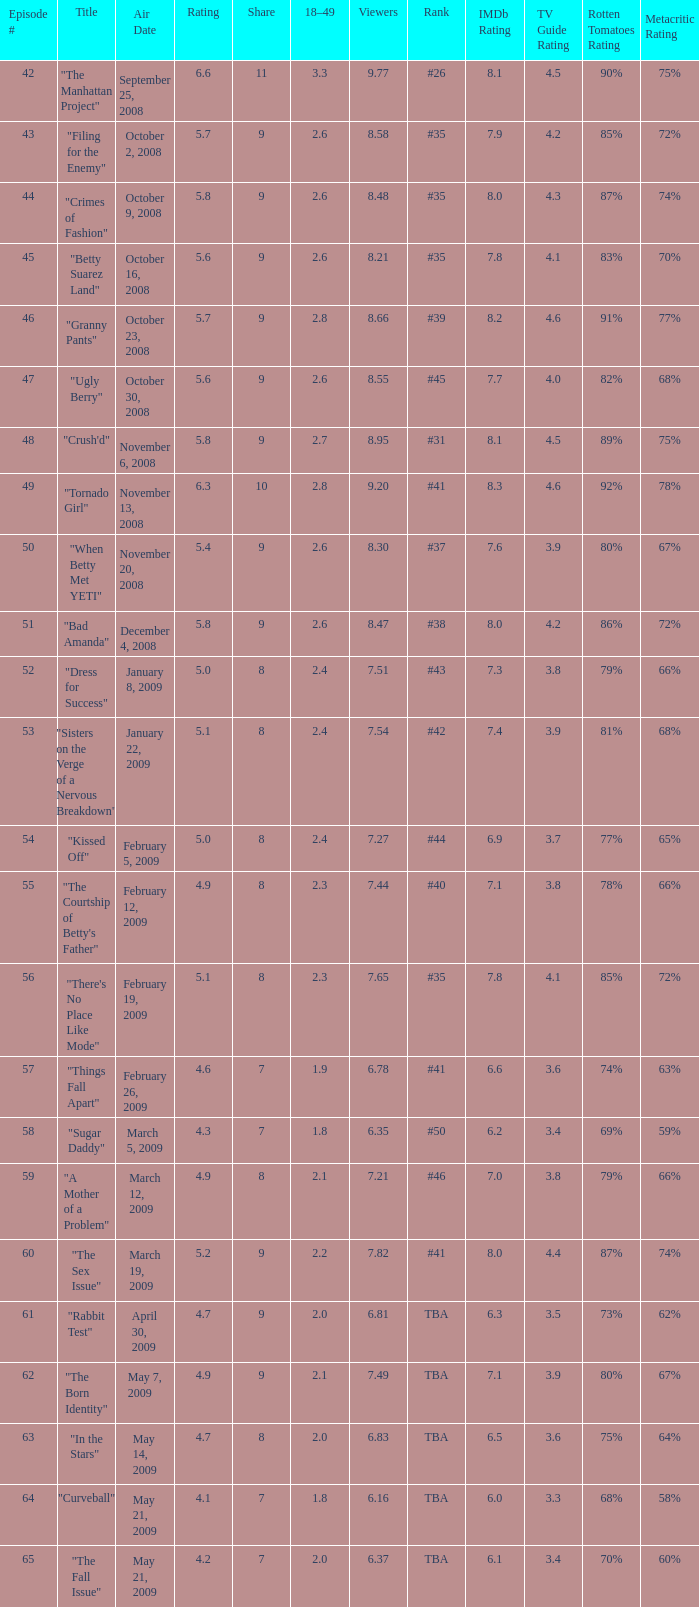What is the total viewer count for a rank of #40? 1.0. Would you mind parsing the complete table? {'header': ['Episode #', 'Title', 'Air Date', 'Rating', 'Share', '18–49', 'Viewers', 'Rank', 'IMDb Rating', 'TV Guide Rating', 'Rotten Tomatoes Rating', 'Metacritic Rating'], 'rows': [['42', '"The Manhattan Project"', 'September 25, 2008', '6.6', '11', '3.3', '9.77', '#26', '8.1', '4.5', '90%', '75%'], ['43', '"Filing for the Enemy"', 'October 2, 2008', '5.7', '9', '2.6', '8.58', '#35', '7.9', '4.2', '85%', '72%'], ['44', '"Crimes of Fashion"', 'October 9, 2008', '5.8', '9', '2.6', '8.48', '#35', '8.0', '4.3', '87%', '74%'], ['45', '"Betty Suarez Land"', 'October 16, 2008', '5.6', '9', '2.6', '8.21', '#35', '7.8', '4.1', '83%', '70%'], ['46', '"Granny Pants"', 'October 23, 2008', '5.7', '9', '2.8', '8.66', '#39', '8.2', '4.6', '91%', '77%'], ['47', '"Ugly Berry"', 'October 30, 2008', '5.6', '9', '2.6', '8.55', '#45', '7.7', '4.0', '82%', '68%'], ['48', '"Crush\'d"', 'November 6, 2008', '5.8', '9', '2.7', '8.95', '#31', '8.1', '4.5', '89%', '75%'], ['49', '"Tornado Girl"', 'November 13, 2008', '6.3', '10', '2.8', '9.20', '#41', '8.3', '4.6', '92%', '78%'], ['50', '"When Betty Met YETI"', 'November 20, 2008', '5.4', '9', '2.6', '8.30', '#37', '7.6', '3.9', '80%', '67%'], ['51', '"Bad Amanda"', 'December 4, 2008', '5.8', '9', '2.6', '8.47', '#38', '8.0', '4.2', '86%', '72%'], ['52', '"Dress for Success"', 'January 8, 2009', '5.0', '8', '2.4', '7.51', '#43', '7.3', '3.8', '79%', '66%'], ['53', '"Sisters on the Verge of a Nervous Breakdown"', 'January 22, 2009', '5.1', '8', '2.4', '7.54', '#42', '7.4', '3.9', '81%', '68%'], ['54', '"Kissed Off"', 'February 5, 2009', '5.0', '8', '2.4', '7.27', '#44', '6.9', '3.7', '77%', '65%'], ['55', '"The Courtship of Betty\'s Father"', 'February 12, 2009', '4.9', '8', '2.3', '7.44', '#40', '7.1', '3.8', '78%', '66%'], ['56', '"There\'s No Place Like Mode"', 'February 19, 2009', '5.1', '8', '2.3', '7.65', '#35', '7.8', '4.1', '85%', '72%'], ['57', '"Things Fall Apart"', 'February 26, 2009', '4.6', '7', '1.9', '6.78', '#41', '6.6', '3.6', '74%', '63%'], ['58', '"Sugar Daddy"', 'March 5, 2009', '4.3', '7', '1.8', '6.35', '#50', '6.2', '3.4', '69%', '59%'], ['59', '"A Mother of a Problem"', 'March 12, 2009', '4.9', '8', '2.1', '7.21', '#46', '7.0', '3.8', '79%', '66%'], ['60', '"The Sex Issue"', 'March 19, 2009', '5.2', '9', '2.2', '7.82', '#41', '8.0', '4.4', '87%', '74%'], ['61', '"Rabbit Test"', 'April 30, 2009', '4.7', '9', '2.0', '6.81', 'TBA', '6.3', '3.5', '73%', '62%'], ['62', '"The Born Identity"', 'May 7, 2009', '4.9', '9', '2.1', '7.49', 'TBA', '7.1', '3.9', '80%', '67%'], ['63', '"In the Stars"', 'May 14, 2009', '4.7', '8', '2.0', '6.83', 'TBA', '6.5', '3.6', '75%', '64%'], ['64', '"Curveball"', 'May 21, 2009', '4.1', '7', '1.8', '6.16', 'TBA', '6.0', '3.3', '68%', '58%'], ['65', '"The Fall Issue"', 'May 21, 2009', '4.2', '7', '2.0', '6.37', 'TBA', '6.1', '3.4', '70%', '60%']]} 